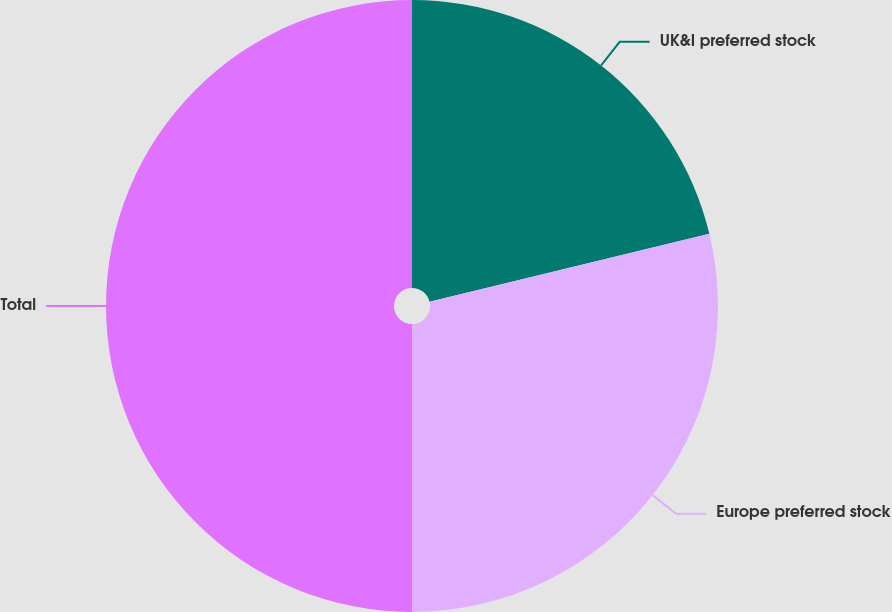Convert chart to OTSL. <chart><loc_0><loc_0><loc_500><loc_500><pie_chart><fcel>UK&I preferred stock<fcel>Europe preferred stock<fcel>Total<nl><fcel>21.21%<fcel>28.79%<fcel>50.0%<nl></chart> 